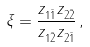<formula> <loc_0><loc_0><loc_500><loc_500>\xi = \frac { z _ { 1 \bar { 1 } } z _ { 2 \bar { 2 } } } { z _ { 1 \bar { 2 } } z _ { 2 \bar { 1 } } } \, ,</formula> 